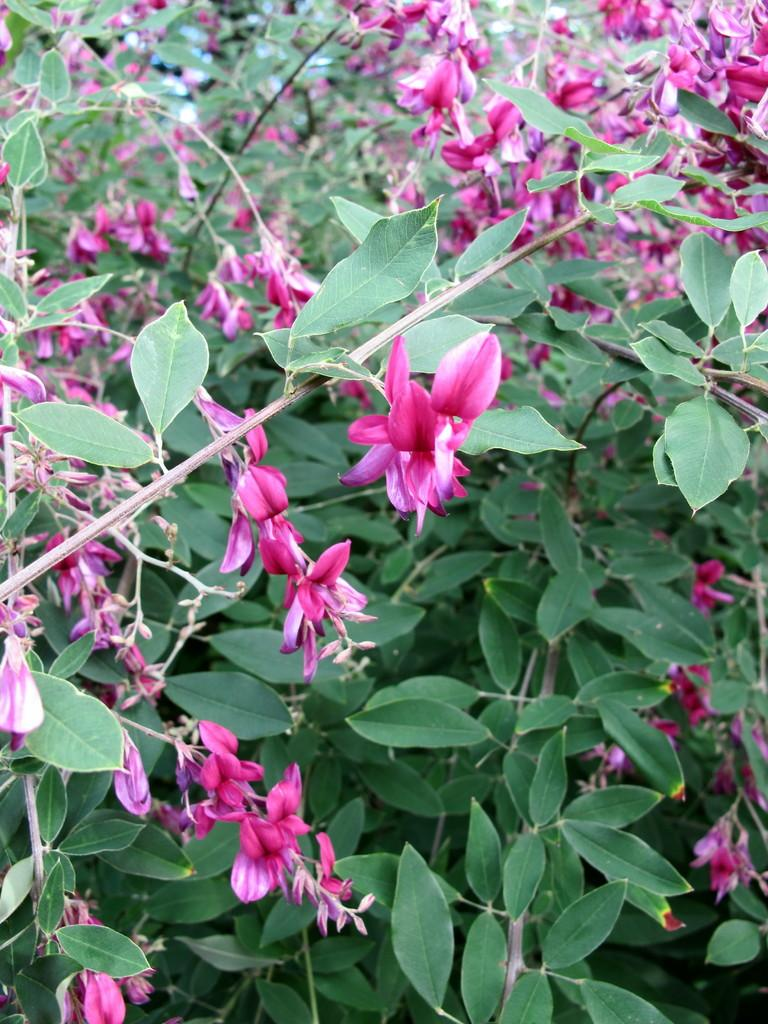What type of vegetation is present in the image? There are trees in the image. What additional features can be observed on the trees? The trees have flowers and buds. Where is the giraffe standing in the image? There is no giraffe present in the image. What type of bread is visible in the image? There is no loaf of bread present in the image. 